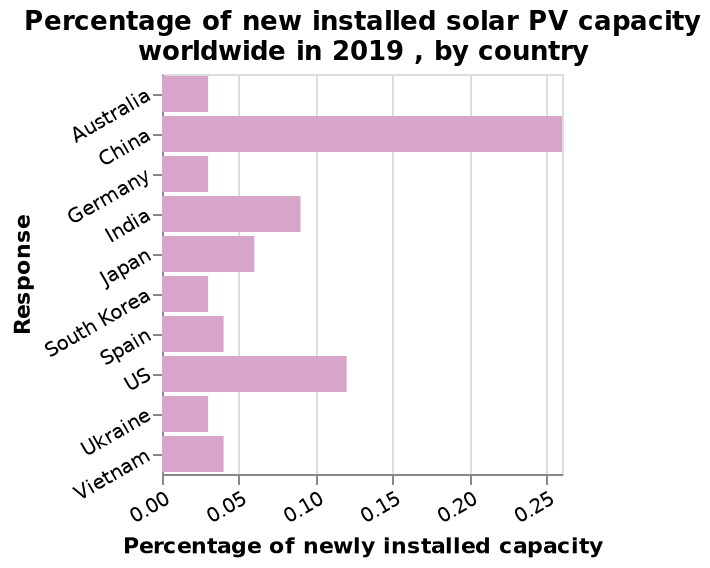<image>
In 2019, which two countries had the highest installed solar PV percentages? China and US. 